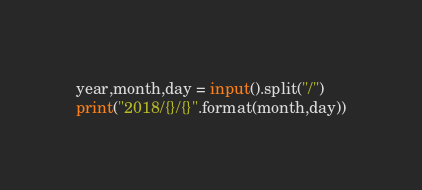<code> <loc_0><loc_0><loc_500><loc_500><_Python_>year,month,day = input().split("/")
print("2018/{}/{}".format(month,day))</code> 